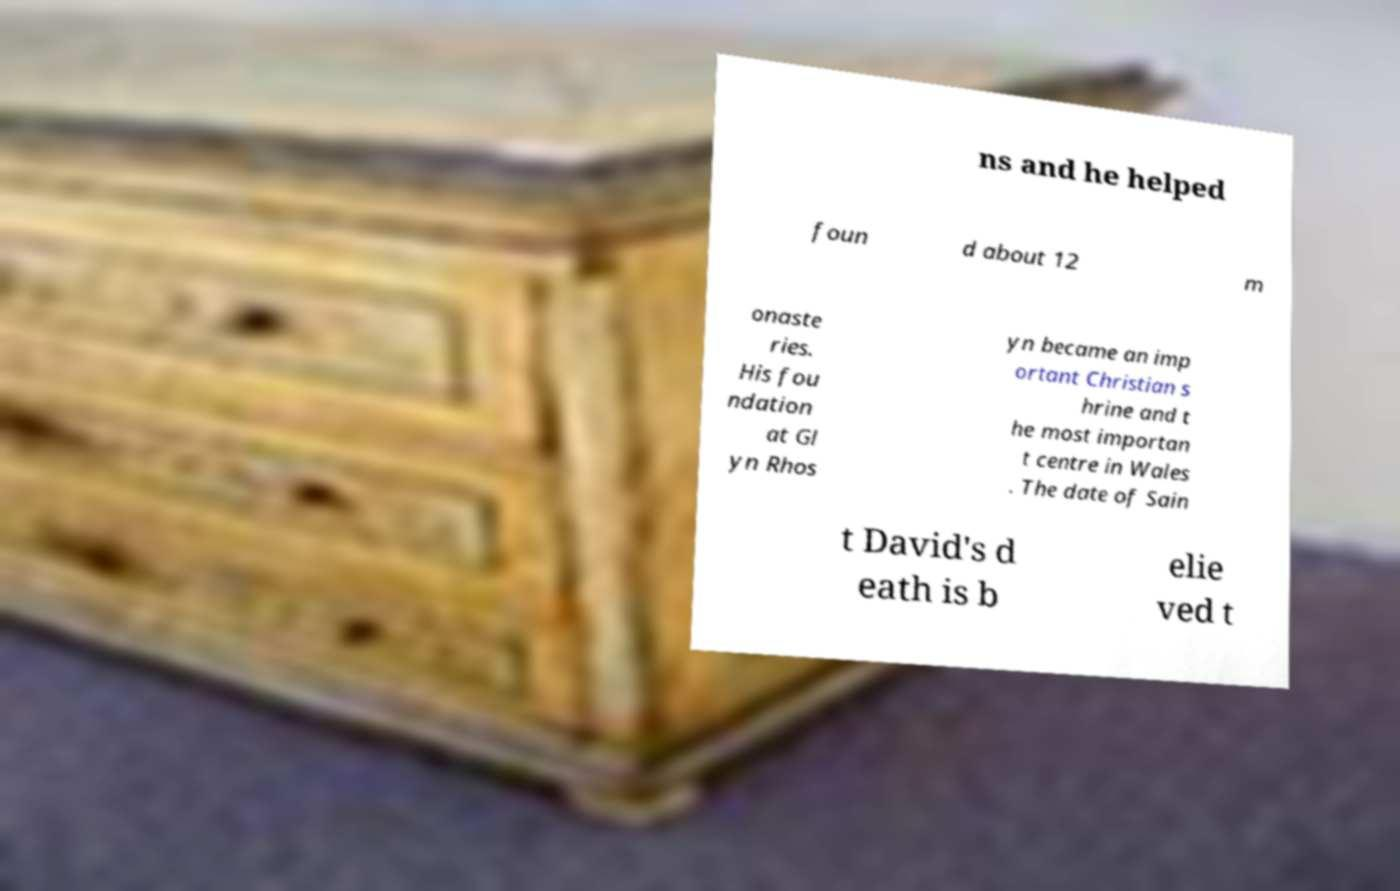There's text embedded in this image that I need extracted. Can you transcribe it verbatim? ns and he helped foun d about 12 m onaste ries. His fou ndation at Gl yn Rhos yn became an imp ortant Christian s hrine and t he most importan t centre in Wales . The date of Sain t David's d eath is b elie ved t 